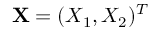<formula> <loc_0><loc_0><loc_500><loc_500>X = ( X _ { 1 } , X _ { 2 } ) ^ { T }</formula> 